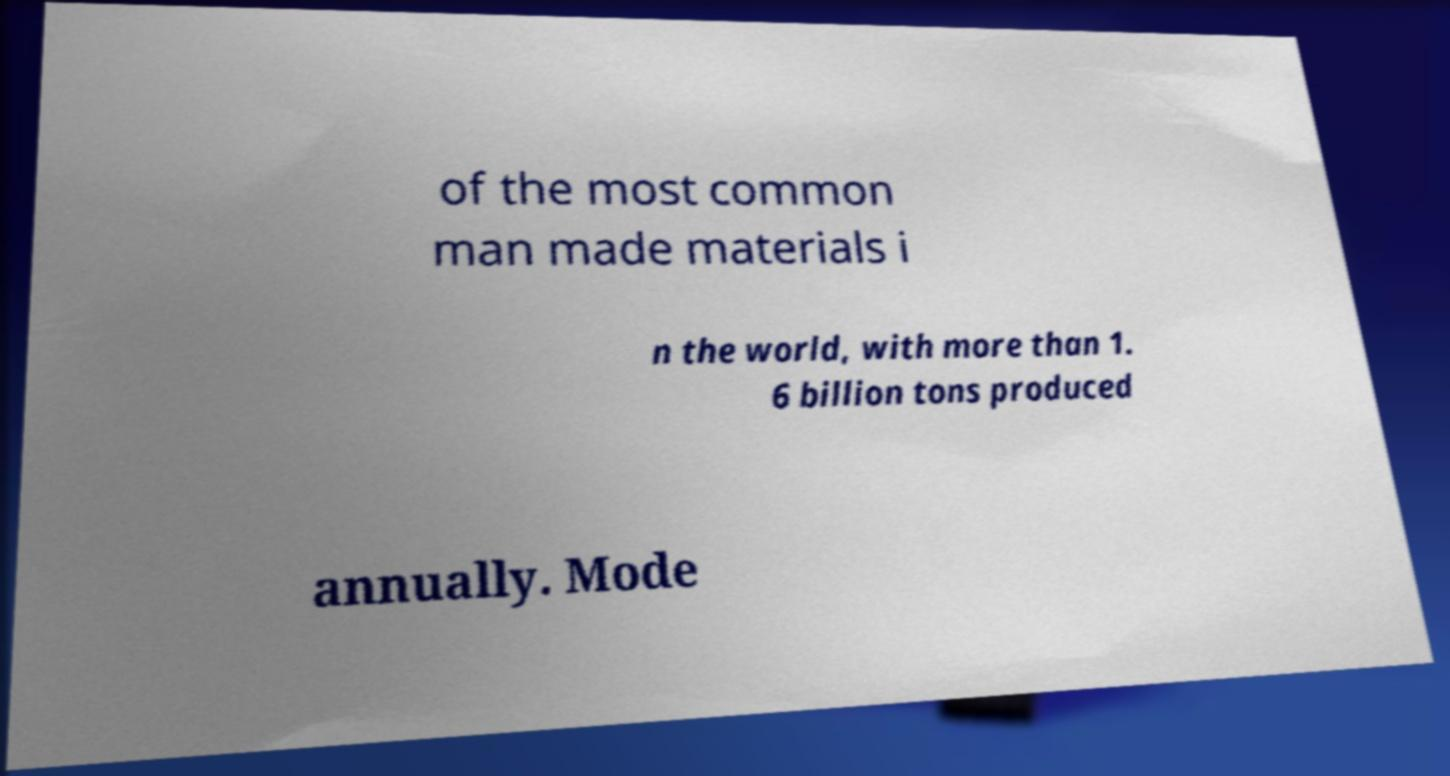Can you read and provide the text displayed in the image?This photo seems to have some interesting text. Can you extract and type it out for me? of the most common man made materials i n the world, with more than 1. 6 billion tons produced annually. Mode 